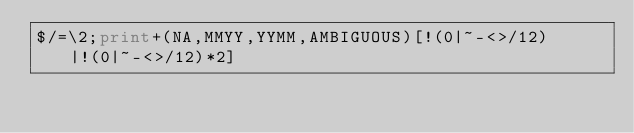<code> <loc_0><loc_0><loc_500><loc_500><_Perl_>$/=\2;print+(NA,MMYY,YYMM,AMBIGUOUS)[!(0|~-<>/12)|!(0|~-<>/12)*2]</code> 